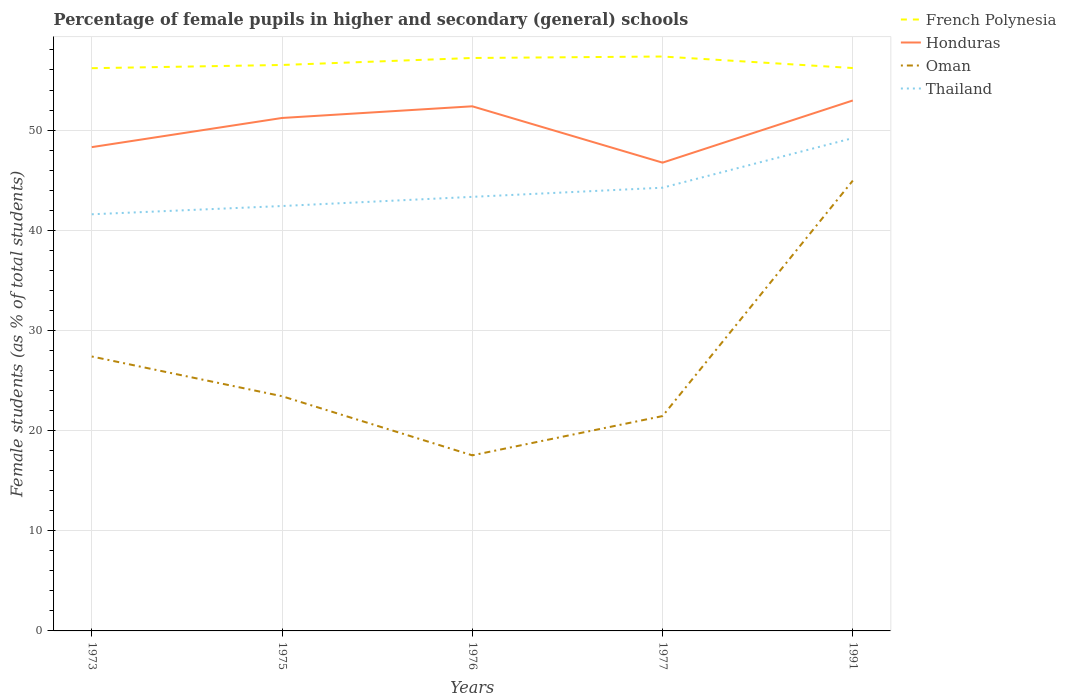Does the line corresponding to Honduras intersect with the line corresponding to Oman?
Keep it short and to the point. No. Across all years, what is the maximum percentage of female pupils in higher and secondary schools in French Polynesia?
Provide a succinct answer. 56.18. In which year was the percentage of female pupils in higher and secondary schools in Oman maximum?
Provide a succinct answer. 1976. What is the total percentage of female pupils in higher and secondary schools in Oman in the graph?
Make the answer very short. -27.43. What is the difference between the highest and the second highest percentage of female pupils in higher and secondary schools in French Polynesia?
Your response must be concise. 1.17. How many lines are there?
Your answer should be very brief. 4. How many years are there in the graph?
Your answer should be very brief. 5. What is the difference between two consecutive major ticks on the Y-axis?
Offer a terse response. 10. Are the values on the major ticks of Y-axis written in scientific E-notation?
Provide a short and direct response. No. Does the graph contain any zero values?
Offer a terse response. No. Does the graph contain grids?
Offer a very short reply. Yes. Where does the legend appear in the graph?
Your answer should be very brief. Top right. How are the legend labels stacked?
Give a very brief answer. Vertical. What is the title of the graph?
Your answer should be compact. Percentage of female pupils in higher and secondary (general) schools. What is the label or title of the Y-axis?
Provide a short and direct response. Female students (as % of total students). What is the Female students (as % of total students) in French Polynesia in 1973?
Your response must be concise. 56.18. What is the Female students (as % of total students) of Honduras in 1973?
Provide a succinct answer. 48.3. What is the Female students (as % of total students) in Oman in 1973?
Your answer should be very brief. 27.4. What is the Female students (as % of total students) in Thailand in 1973?
Offer a terse response. 41.59. What is the Female students (as % of total students) in French Polynesia in 1975?
Give a very brief answer. 56.5. What is the Female students (as % of total students) of Honduras in 1975?
Offer a very short reply. 51.21. What is the Female students (as % of total students) of Oman in 1975?
Your answer should be very brief. 23.43. What is the Female students (as % of total students) in Thailand in 1975?
Offer a terse response. 42.42. What is the Female students (as % of total students) of French Polynesia in 1976?
Your answer should be very brief. 57.2. What is the Female students (as % of total students) of Honduras in 1976?
Your answer should be compact. 52.37. What is the Female students (as % of total students) of Oman in 1976?
Give a very brief answer. 17.53. What is the Female students (as % of total students) in Thailand in 1976?
Ensure brevity in your answer.  43.33. What is the Female students (as % of total students) in French Polynesia in 1977?
Ensure brevity in your answer.  57.34. What is the Female students (as % of total students) in Honduras in 1977?
Your response must be concise. 46.75. What is the Female students (as % of total students) in Oman in 1977?
Offer a very short reply. 21.45. What is the Female students (as % of total students) in Thailand in 1977?
Make the answer very short. 44.25. What is the Female students (as % of total students) of French Polynesia in 1991?
Make the answer very short. 56.19. What is the Female students (as % of total students) of Honduras in 1991?
Keep it short and to the point. 52.96. What is the Female students (as % of total students) of Oman in 1991?
Offer a very short reply. 44.96. What is the Female students (as % of total students) in Thailand in 1991?
Your answer should be very brief. 49.2. Across all years, what is the maximum Female students (as % of total students) in French Polynesia?
Offer a terse response. 57.34. Across all years, what is the maximum Female students (as % of total students) in Honduras?
Provide a short and direct response. 52.96. Across all years, what is the maximum Female students (as % of total students) in Oman?
Provide a succinct answer. 44.96. Across all years, what is the maximum Female students (as % of total students) in Thailand?
Make the answer very short. 49.2. Across all years, what is the minimum Female students (as % of total students) in French Polynesia?
Your answer should be compact. 56.18. Across all years, what is the minimum Female students (as % of total students) in Honduras?
Provide a short and direct response. 46.75. Across all years, what is the minimum Female students (as % of total students) of Oman?
Give a very brief answer. 17.53. Across all years, what is the minimum Female students (as % of total students) of Thailand?
Provide a succinct answer. 41.59. What is the total Female students (as % of total students) of French Polynesia in the graph?
Make the answer very short. 283.42. What is the total Female students (as % of total students) of Honduras in the graph?
Your response must be concise. 251.59. What is the total Female students (as % of total students) of Oman in the graph?
Offer a terse response. 134.76. What is the total Female students (as % of total students) of Thailand in the graph?
Your response must be concise. 220.79. What is the difference between the Female students (as % of total students) of French Polynesia in 1973 and that in 1975?
Your response must be concise. -0.32. What is the difference between the Female students (as % of total students) in Honduras in 1973 and that in 1975?
Your answer should be very brief. -2.91. What is the difference between the Female students (as % of total students) of Oman in 1973 and that in 1975?
Make the answer very short. 3.97. What is the difference between the Female students (as % of total students) in Thailand in 1973 and that in 1975?
Keep it short and to the point. -0.82. What is the difference between the Female students (as % of total students) of French Polynesia in 1973 and that in 1976?
Provide a short and direct response. -1.02. What is the difference between the Female students (as % of total students) of Honduras in 1973 and that in 1976?
Your answer should be very brief. -4.08. What is the difference between the Female students (as % of total students) of Oman in 1973 and that in 1976?
Provide a succinct answer. 9.87. What is the difference between the Female students (as % of total students) in Thailand in 1973 and that in 1976?
Give a very brief answer. -1.74. What is the difference between the Female students (as % of total students) in French Polynesia in 1973 and that in 1977?
Your answer should be compact. -1.17. What is the difference between the Female students (as % of total students) of Honduras in 1973 and that in 1977?
Provide a short and direct response. 1.55. What is the difference between the Female students (as % of total students) of Oman in 1973 and that in 1977?
Give a very brief answer. 5.95. What is the difference between the Female students (as % of total students) in Thailand in 1973 and that in 1977?
Your answer should be compact. -2.65. What is the difference between the Female students (as % of total students) of French Polynesia in 1973 and that in 1991?
Provide a succinct answer. -0.02. What is the difference between the Female students (as % of total students) of Honduras in 1973 and that in 1991?
Provide a short and direct response. -4.66. What is the difference between the Female students (as % of total students) of Oman in 1973 and that in 1991?
Provide a succinct answer. -17.56. What is the difference between the Female students (as % of total students) of Thailand in 1973 and that in 1991?
Offer a very short reply. -7.6. What is the difference between the Female students (as % of total students) of French Polynesia in 1975 and that in 1976?
Make the answer very short. -0.7. What is the difference between the Female students (as % of total students) of Honduras in 1975 and that in 1976?
Keep it short and to the point. -1.16. What is the difference between the Female students (as % of total students) of Oman in 1975 and that in 1976?
Offer a terse response. 5.9. What is the difference between the Female students (as % of total students) of Thailand in 1975 and that in 1976?
Ensure brevity in your answer.  -0.92. What is the difference between the Female students (as % of total students) in French Polynesia in 1975 and that in 1977?
Offer a terse response. -0.84. What is the difference between the Female students (as % of total students) of Honduras in 1975 and that in 1977?
Make the answer very short. 4.46. What is the difference between the Female students (as % of total students) in Oman in 1975 and that in 1977?
Ensure brevity in your answer.  1.98. What is the difference between the Female students (as % of total students) in Thailand in 1975 and that in 1977?
Keep it short and to the point. -1.83. What is the difference between the Female students (as % of total students) in French Polynesia in 1975 and that in 1991?
Give a very brief answer. 0.31. What is the difference between the Female students (as % of total students) in Honduras in 1975 and that in 1991?
Give a very brief answer. -1.75. What is the difference between the Female students (as % of total students) in Oman in 1975 and that in 1991?
Your response must be concise. -21.53. What is the difference between the Female students (as % of total students) of Thailand in 1975 and that in 1991?
Provide a succinct answer. -6.78. What is the difference between the Female students (as % of total students) of French Polynesia in 1976 and that in 1977?
Provide a short and direct response. -0.15. What is the difference between the Female students (as % of total students) in Honduras in 1976 and that in 1977?
Your answer should be very brief. 5.62. What is the difference between the Female students (as % of total students) of Oman in 1976 and that in 1977?
Give a very brief answer. -3.92. What is the difference between the Female students (as % of total students) of Thailand in 1976 and that in 1977?
Give a very brief answer. -0.91. What is the difference between the Female students (as % of total students) of French Polynesia in 1976 and that in 1991?
Offer a very short reply. 1. What is the difference between the Female students (as % of total students) of Honduras in 1976 and that in 1991?
Offer a very short reply. -0.58. What is the difference between the Female students (as % of total students) in Oman in 1976 and that in 1991?
Provide a succinct answer. -27.43. What is the difference between the Female students (as % of total students) of Thailand in 1976 and that in 1991?
Your response must be concise. -5.86. What is the difference between the Female students (as % of total students) in French Polynesia in 1977 and that in 1991?
Your answer should be compact. 1.15. What is the difference between the Female students (as % of total students) of Honduras in 1977 and that in 1991?
Your answer should be compact. -6.21. What is the difference between the Female students (as % of total students) of Oman in 1977 and that in 1991?
Your response must be concise. -23.51. What is the difference between the Female students (as % of total students) of Thailand in 1977 and that in 1991?
Offer a very short reply. -4.95. What is the difference between the Female students (as % of total students) of French Polynesia in 1973 and the Female students (as % of total students) of Honduras in 1975?
Keep it short and to the point. 4.97. What is the difference between the Female students (as % of total students) in French Polynesia in 1973 and the Female students (as % of total students) in Oman in 1975?
Make the answer very short. 32.75. What is the difference between the Female students (as % of total students) of French Polynesia in 1973 and the Female students (as % of total students) of Thailand in 1975?
Give a very brief answer. 13.76. What is the difference between the Female students (as % of total students) of Honduras in 1973 and the Female students (as % of total students) of Oman in 1975?
Provide a short and direct response. 24.87. What is the difference between the Female students (as % of total students) in Honduras in 1973 and the Female students (as % of total students) in Thailand in 1975?
Keep it short and to the point. 5.88. What is the difference between the Female students (as % of total students) in Oman in 1973 and the Female students (as % of total students) in Thailand in 1975?
Keep it short and to the point. -15.02. What is the difference between the Female students (as % of total students) of French Polynesia in 1973 and the Female students (as % of total students) of Honduras in 1976?
Ensure brevity in your answer.  3.8. What is the difference between the Female students (as % of total students) in French Polynesia in 1973 and the Female students (as % of total students) in Oman in 1976?
Ensure brevity in your answer.  38.65. What is the difference between the Female students (as % of total students) of French Polynesia in 1973 and the Female students (as % of total students) of Thailand in 1976?
Provide a short and direct response. 12.84. What is the difference between the Female students (as % of total students) of Honduras in 1973 and the Female students (as % of total students) of Oman in 1976?
Your response must be concise. 30.77. What is the difference between the Female students (as % of total students) in Honduras in 1973 and the Female students (as % of total students) in Thailand in 1976?
Offer a very short reply. 4.96. What is the difference between the Female students (as % of total students) in Oman in 1973 and the Female students (as % of total students) in Thailand in 1976?
Offer a very short reply. -15.94. What is the difference between the Female students (as % of total students) of French Polynesia in 1973 and the Female students (as % of total students) of Honduras in 1977?
Ensure brevity in your answer.  9.43. What is the difference between the Female students (as % of total students) of French Polynesia in 1973 and the Female students (as % of total students) of Oman in 1977?
Offer a terse response. 34.73. What is the difference between the Female students (as % of total students) in French Polynesia in 1973 and the Female students (as % of total students) in Thailand in 1977?
Make the answer very short. 11.93. What is the difference between the Female students (as % of total students) in Honduras in 1973 and the Female students (as % of total students) in Oman in 1977?
Your answer should be compact. 26.85. What is the difference between the Female students (as % of total students) of Honduras in 1973 and the Female students (as % of total students) of Thailand in 1977?
Offer a very short reply. 4.05. What is the difference between the Female students (as % of total students) of Oman in 1973 and the Female students (as % of total students) of Thailand in 1977?
Keep it short and to the point. -16.85. What is the difference between the Female students (as % of total students) of French Polynesia in 1973 and the Female students (as % of total students) of Honduras in 1991?
Your response must be concise. 3.22. What is the difference between the Female students (as % of total students) of French Polynesia in 1973 and the Female students (as % of total students) of Oman in 1991?
Provide a short and direct response. 11.22. What is the difference between the Female students (as % of total students) of French Polynesia in 1973 and the Female students (as % of total students) of Thailand in 1991?
Provide a short and direct response. 6.98. What is the difference between the Female students (as % of total students) of Honduras in 1973 and the Female students (as % of total students) of Oman in 1991?
Provide a succinct answer. 3.34. What is the difference between the Female students (as % of total students) in Honduras in 1973 and the Female students (as % of total students) in Thailand in 1991?
Keep it short and to the point. -0.9. What is the difference between the Female students (as % of total students) in Oman in 1973 and the Female students (as % of total students) in Thailand in 1991?
Provide a short and direct response. -21.8. What is the difference between the Female students (as % of total students) of French Polynesia in 1975 and the Female students (as % of total students) of Honduras in 1976?
Offer a terse response. 4.13. What is the difference between the Female students (as % of total students) of French Polynesia in 1975 and the Female students (as % of total students) of Oman in 1976?
Offer a very short reply. 38.97. What is the difference between the Female students (as % of total students) in French Polynesia in 1975 and the Female students (as % of total students) in Thailand in 1976?
Ensure brevity in your answer.  13.17. What is the difference between the Female students (as % of total students) of Honduras in 1975 and the Female students (as % of total students) of Oman in 1976?
Keep it short and to the point. 33.68. What is the difference between the Female students (as % of total students) in Honduras in 1975 and the Female students (as % of total students) in Thailand in 1976?
Give a very brief answer. 7.88. What is the difference between the Female students (as % of total students) of Oman in 1975 and the Female students (as % of total students) of Thailand in 1976?
Give a very brief answer. -19.9. What is the difference between the Female students (as % of total students) of French Polynesia in 1975 and the Female students (as % of total students) of Honduras in 1977?
Ensure brevity in your answer.  9.75. What is the difference between the Female students (as % of total students) in French Polynesia in 1975 and the Female students (as % of total students) in Oman in 1977?
Make the answer very short. 35.05. What is the difference between the Female students (as % of total students) of French Polynesia in 1975 and the Female students (as % of total students) of Thailand in 1977?
Your response must be concise. 12.25. What is the difference between the Female students (as % of total students) of Honduras in 1975 and the Female students (as % of total students) of Oman in 1977?
Offer a terse response. 29.76. What is the difference between the Female students (as % of total students) of Honduras in 1975 and the Female students (as % of total students) of Thailand in 1977?
Ensure brevity in your answer.  6.96. What is the difference between the Female students (as % of total students) of Oman in 1975 and the Female students (as % of total students) of Thailand in 1977?
Your response must be concise. -20.82. What is the difference between the Female students (as % of total students) in French Polynesia in 1975 and the Female students (as % of total students) in Honduras in 1991?
Keep it short and to the point. 3.54. What is the difference between the Female students (as % of total students) in French Polynesia in 1975 and the Female students (as % of total students) in Oman in 1991?
Offer a terse response. 11.54. What is the difference between the Female students (as % of total students) in French Polynesia in 1975 and the Female students (as % of total students) in Thailand in 1991?
Your answer should be very brief. 7.3. What is the difference between the Female students (as % of total students) in Honduras in 1975 and the Female students (as % of total students) in Oman in 1991?
Offer a very short reply. 6.25. What is the difference between the Female students (as % of total students) in Honduras in 1975 and the Female students (as % of total students) in Thailand in 1991?
Your answer should be very brief. 2.01. What is the difference between the Female students (as % of total students) in Oman in 1975 and the Female students (as % of total students) in Thailand in 1991?
Offer a very short reply. -25.77. What is the difference between the Female students (as % of total students) of French Polynesia in 1976 and the Female students (as % of total students) of Honduras in 1977?
Make the answer very short. 10.45. What is the difference between the Female students (as % of total students) in French Polynesia in 1976 and the Female students (as % of total students) in Oman in 1977?
Ensure brevity in your answer.  35.75. What is the difference between the Female students (as % of total students) of French Polynesia in 1976 and the Female students (as % of total students) of Thailand in 1977?
Provide a short and direct response. 12.95. What is the difference between the Female students (as % of total students) of Honduras in 1976 and the Female students (as % of total students) of Oman in 1977?
Your answer should be very brief. 30.92. What is the difference between the Female students (as % of total students) in Honduras in 1976 and the Female students (as % of total students) in Thailand in 1977?
Offer a very short reply. 8.13. What is the difference between the Female students (as % of total students) of Oman in 1976 and the Female students (as % of total students) of Thailand in 1977?
Provide a succinct answer. -26.72. What is the difference between the Female students (as % of total students) of French Polynesia in 1976 and the Female students (as % of total students) of Honduras in 1991?
Your response must be concise. 4.24. What is the difference between the Female students (as % of total students) of French Polynesia in 1976 and the Female students (as % of total students) of Oman in 1991?
Ensure brevity in your answer.  12.24. What is the difference between the Female students (as % of total students) of French Polynesia in 1976 and the Female students (as % of total students) of Thailand in 1991?
Offer a terse response. 8. What is the difference between the Female students (as % of total students) in Honduras in 1976 and the Female students (as % of total students) in Oman in 1991?
Make the answer very short. 7.42. What is the difference between the Female students (as % of total students) in Honduras in 1976 and the Female students (as % of total students) in Thailand in 1991?
Provide a succinct answer. 3.18. What is the difference between the Female students (as % of total students) in Oman in 1976 and the Female students (as % of total students) in Thailand in 1991?
Ensure brevity in your answer.  -31.67. What is the difference between the Female students (as % of total students) in French Polynesia in 1977 and the Female students (as % of total students) in Honduras in 1991?
Provide a short and direct response. 4.39. What is the difference between the Female students (as % of total students) of French Polynesia in 1977 and the Female students (as % of total students) of Oman in 1991?
Your answer should be very brief. 12.39. What is the difference between the Female students (as % of total students) in French Polynesia in 1977 and the Female students (as % of total students) in Thailand in 1991?
Ensure brevity in your answer.  8.15. What is the difference between the Female students (as % of total students) in Honduras in 1977 and the Female students (as % of total students) in Oman in 1991?
Your answer should be very brief. 1.79. What is the difference between the Female students (as % of total students) in Honduras in 1977 and the Female students (as % of total students) in Thailand in 1991?
Provide a succinct answer. -2.45. What is the difference between the Female students (as % of total students) in Oman in 1977 and the Female students (as % of total students) in Thailand in 1991?
Provide a short and direct response. -27.75. What is the average Female students (as % of total students) in French Polynesia per year?
Provide a succinct answer. 56.68. What is the average Female students (as % of total students) in Honduras per year?
Keep it short and to the point. 50.32. What is the average Female students (as % of total students) of Oman per year?
Your response must be concise. 26.95. What is the average Female students (as % of total students) in Thailand per year?
Your answer should be compact. 44.16. In the year 1973, what is the difference between the Female students (as % of total students) in French Polynesia and Female students (as % of total students) in Honduras?
Offer a very short reply. 7.88. In the year 1973, what is the difference between the Female students (as % of total students) of French Polynesia and Female students (as % of total students) of Oman?
Provide a succinct answer. 28.78. In the year 1973, what is the difference between the Female students (as % of total students) in French Polynesia and Female students (as % of total students) in Thailand?
Make the answer very short. 14.58. In the year 1973, what is the difference between the Female students (as % of total students) of Honduras and Female students (as % of total students) of Oman?
Offer a terse response. 20.9. In the year 1973, what is the difference between the Female students (as % of total students) in Honduras and Female students (as % of total students) in Thailand?
Give a very brief answer. 6.7. In the year 1973, what is the difference between the Female students (as % of total students) of Oman and Female students (as % of total students) of Thailand?
Provide a short and direct response. -14.2. In the year 1975, what is the difference between the Female students (as % of total students) in French Polynesia and Female students (as % of total students) in Honduras?
Provide a succinct answer. 5.29. In the year 1975, what is the difference between the Female students (as % of total students) in French Polynesia and Female students (as % of total students) in Oman?
Your answer should be compact. 33.07. In the year 1975, what is the difference between the Female students (as % of total students) of French Polynesia and Female students (as % of total students) of Thailand?
Keep it short and to the point. 14.08. In the year 1975, what is the difference between the Female students (as % of total students) of Honduras and Female students (as % of total students) of Oman?
Offer a very short reply. 27.78. In the year 1975, what is the difference between the Female students (as % of total students) of Honduras and Female students (as % of total students) of Thailand?
Give a very brief answer. 8.79. In the year 1975, what is the difference between the Female students (as % of total students) of Oman and Female students (as % of total students) of Thailand?
Give a very brief answer. -18.99. In the year 1976, what is the difference between the Female students (as % of total students) of French Polynesia and Female students (as % of total students) of Honduras?
Offer a terse response. 4.82. In the year 1976, what is the difference between the Female students (as % of total students) in French Polynesia and Female students (as % of total students) in Oman?
Make the answer very short. 39.67. In the year 1976, what is the difference between the Female students (as % of total students) of French Polynesia and Female students (as % of total students) of Thailand?
Your answer should be compact. 13.86. In the year 1976, what is the difference between the Female students (as % of total students) in Honduras and Female students (as % of total students) in Oman?
Give a very brief answer. 34.85. In the year 1976, what is the difference between the Female students (as % of total students) in Honduras and Female students (as % of total students) in Thailand?
Your answer should be very brief. 9.04. In the year 1976, what is the difference between the Female students (as % of total students) in Oman and Female students (as % of total students) in Thailand?
Give a very brief answer. -25.81. In the year 1977, what is the difference between the Female students (as % of total students) of French Polynesia and Female students (as % of total students) of Honduras?
Keep it short and to the point. 10.6. In the year 1977, what is the difference between the Female students (as % of total students) in French Polynesia and Female students (as % of total students) in Oman?
Provide a succinct answer. 35.89. In the year 1977, what is the difference between the Female students (as % of total students) in French Polynesia and Female students (as % of total students) in Thailand?
Offer a terse response. 13.1. In the year 1977, what is the difference between the Female students (as % of total students) of Honduras and Female students (as % of total students) of Oman?
Ensure brevity in your answer.  25.3. In the year 1977, what is the difference between the Female students (as % of total students) in Honduras and Female students (as % of total students) in Thailand?
Provide a short and direct response. 2.5. In the year 1977, what is the difference between the Female students (as % of total students) in Oman and Female students (as % of total students) in Thailand?
Provide a succinct answer. -22.8. In the year 1991, what is the difference between the Female students (as % of total students) of French Polynesia and Female students (as % of total students) of Honduras?
Offer a terse response. 3.24. In the year 1991, what is the difference between the Female students (as % of total students) in French Polynesia and Female students (as % of total students) in Oman?
Make the answer very short. 11.24. In the year 1991, what is the difference between the Female students (as % of total students) of French Polynesia and Female students (as % of total students) of Thailand?
Give a very brief answer. 7. In the year 1991, what is the difference between the Female students (as % of total students) in Honduras and Female students (as % of total students) in Oman?
Your answer should be compact. 8. In the year 1991, what is the difference between the Female students (as % of total students) in Honduras and Female students (as % of total students) in Thailand?
Provide a succinct answer. 3.76. In the year 1991, what is the difference between the Female students (as % of total students) of Oman and Female students (as % of total students) of Thailand?
Provide a short and direct response. -4.24. What is the ratio of the Female students (as % of total students) of Honduras in 1973 to that in 1975?
Your answer should be compact. 0.94. What is the ratio of the Female students (as % of total students) in Oman in 1973 to that in 1975?
Make the answer very short. 1.17. What is the ratio of the Female students (as % of total students) of Thailand in 1973 to that in 1975?
Offer a very short reply. 0.98. What is the ratio of the Female students (as % of total students) of French Polynesia in 1973 to that in 1976?
Provide a succinct answer. 0.98. What is the ratio of the Female students (as % of total students) of Honduras in 1973 to that in 1976?
Offer a terse response. 0.92. What is the ratio of the Female students (as % of total students) of Oman in 1973 to that in 1976?
Ensure brevity in your answer.  1.56. What is the ratio of the Female students (as % of total students) of Thailand in 1973 to that in 1976?
Provide a short and direct response. 0.96. What is the ratio of the Female students (as % of total students) in French Polynesia in 1973 to that in 1977?
Give a very brief answer. 0.98. What is the ratio of the Female students (as % of total students) in Honduras in 1973 to that in 1977?
Provide a short and direct response. 1.03. What is the ratio of the Female students (as % of total students) in Oman in 1973 to that in 1977?
Your response must be concise. 1.28. What is the ratio of the Female students (as % of total students) in French Polynesia in 1973 to that in 1991?
Your answer should be very brief. 1. What is the ratio of the Female students (as % of total students) of Honduras in 1973 to that in 1991?
Provide a succinct answer. 0.91. What is the ratio of the Female students (as % of total students) of Oman in 1973 to that in 1991?
Your response must be concise. 0.61. What is the ratio of the Female students (as % of total students) in Thailand in 1973 to that in 1991?
Make the answer very short. 0.85. What is the ratio of the Female students (as % of total students) of Honduras in 1975 to that in 1976?
Provide a short and direct response. 0.98. What is the ratio of the Female students (as % of total students) in Oman in 1975 to that in 1976?
Your response must be concise. 1.34. What is the ratio of the Female students (as % of total students) of Thailand in 1975 to that in 1976?
Offer a terse response. 0.98. What is the ratio of the Female students (as % of total students) of Honduras in 1975 to that in 1977?
Provide a succinct answer. 1.1. What is the ratio of the Female students (as % of total students) in Oman in 1975 to that in 1977?
Provide a succinct answer. 1.09. What is the ratio of the Female students (as % of total students) of Thailand in 1975 to that in 1977?
Your answer should be very brief. 0.96. What is the ratio of the Female students (as % of total students) of French Polynesia in 1975 to that in 1991?
Your response must be concise. 1.01. What is the ratio of the Female students (as % of total students) in Honduras in 1975 to that in 1991?
Make the answer very short. 0.97. What is the ratio of the Female students (as % of total students) of Oman in 1975 to that in 1991?
Offer a terse response. 0.52. What is the ratio of the Female students (as % of total students) in Thailand in 1975 to that in 1991?
Give a very brief answer. 0.86. What is the ratio of the Female students (as % of total students) in French Polynesia in 1976 to that in 1977?
Your response must be concise. 1. What is the ratio of the Female students (as % of total students) in Honduras in 1976 to that in 1977?
Provide a short and direct response. 1.12. What is the ratio of the Female students (as % of total students) in Oman in 1976 to that in 1977?
Your answer should be very brief. 0.82. What is the ratio of the Female students (as % of total students) in Thailand in 1976 to that in 1977?
Your answer should be very brief. 0.98. What is the ratio of the Female students (as % of total students) in French Polynesia in 1976 to that in 1991?
Provide a short and direct response. 1.02. What is the ratio of the Female students (as % of total students) in Honduras in 1976 to that in 1991?
Provide a succinct answer. 0.99. What is the ratio of the Female students (as % of total students) of Oman in 1976 to that in 1991?
Your response must be concise. 0.39. What is the ratio of the Female students (as % of total students) of Thailand in 1976 to that in 1991?
Give a very brief answer. 0.88. What is the ratio of the Female students (as % of total students) in French Polynesia in 1977 to that in 1991?
Offer a terse response. 1.02. What is the ratio of the Female students (as % of total students) in Honduras in 1977 to that in 1991?
Keep it short and to the point. 0.88. What is the ratio of the Female students (as % of total students) of Oman in 1977 to that in 1991?
Offer a very short reply. 0.48. What is the ratio of the Female students (as % of total students) in Thailand in 1977 to that in 1991?
Provide a short and direct response. 0.9. What is the difference between the highest and the second highest Female students (as % of total students) in French Polynesia?
Give a very brief answer. 0.15. What is the difference between the highest and the second highest Female students (as % of total students) of Honduras?
Make the answer very short. 0.58. What is the difference between the highest and the second highest Female students (as % of total students) of Oman?
Offer a very short reply. 17.56. What is the difference between the highest and the second highest Female students (as % of total students) of Thailand?
Provide a short and direct response. 4.95. What is the difference between the highest and the lowest Female students (as % of total students) in French Polynesia?
Keep it short and to the point. 1.17. What is the difference between the highest and the lowest Female students (as % of total students) of Honduras?
Ensure brevity in your answer.  6.21. What is the difference between the highest and the lowest Female students (as % of total students) in Oman?
Provide a succinct answer. 27.43. What is the difference between the highest and the lowest Female students (as % of total students) of Thailand?
Make the answer very short. 7.6. 